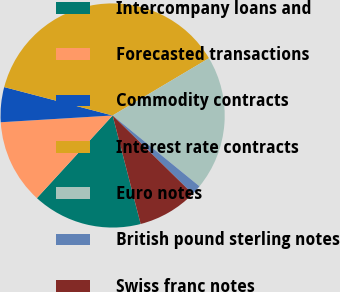Convert chart. <chart><loc_0><loc_0><loc_500><loc_500><pie_chart><fcel>Intercompany loans and<fcel>Forecasted transactions<fcel>Commodity contracts<fcel>Interest rate contracts<fcel>Euro notes<fcel>British pound sterling notes<fcel>Swiss franc notes<nl><fcel>15.83%<fcel>12.23%<fcel>5.04%<fcel>37.39%<fcel>19.42%<fcel>1.45%<fcel>8.64%<nl></chart> 